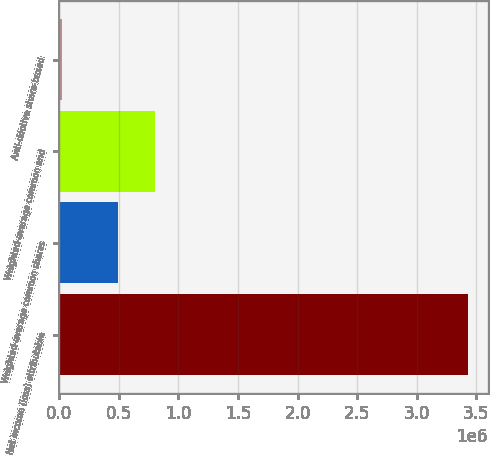<chart> <loc_0><loc_0><loc_500><loc_500><bar_chart><fcel>Net income (loss) attributable<fcel>Weighted-average common shares<fcel>Weighted-average common and<fcel>Anti-dilutive share-based<nl><fcel>3.42775e+06<fcel>488652<fcel>801762<fcel>21886<nl></chart> 